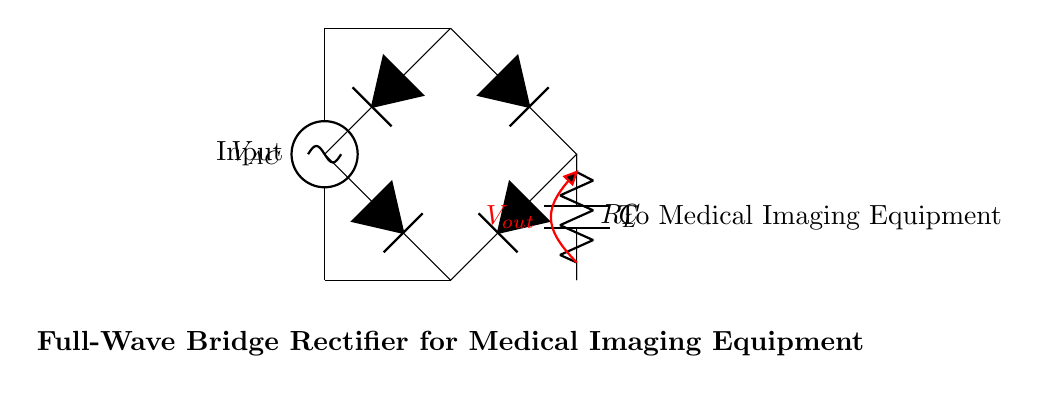What type of rectifier is shown in the circuit? The circuit diagram depicts a full-wave bridge rectifier, which utilizes diodes to rectify both halves of the AC input signal.
Answer: full-wave bridge rectifier What is the load resistor labeled as in the circuit? The load resistor is labeled as R sub L, which indicates the component that will supply power to the medical imaging equipment.
Answer: R sub L How many diodes are used in this circuit? The full-wave bridge rectifier circuit utilizes four diodes to allow current to flow in both directions, ensuring a smooth output voltage.
Answer: four What is the purpose of the smoothing capacitor in this circuit? The smoothing capacitor is used to reduce the ripple in the output voltage, providing a more stable DC voltage for the medical imaging equipment.
Answer: reduce ripple What is the output voltage labeled as in the circuit? The output voltage is indicated as V sub out, denoting the voltage delivered to the load resistor and medical imaging equipment.
Answer: V sub out In which direction does current flow during the positive half-cycle of the AC input? During the positive half-cycle, current flows from the AC source through the diodes towards the load resistor and capacitor, following the path determined by the diodes' orientation.
Answer: forward What type of equipment is this circuit powering? The circuit is designed to power medical imaging equipment, indicating its application in healthcare technology.
Answer: medical imaging equipment 